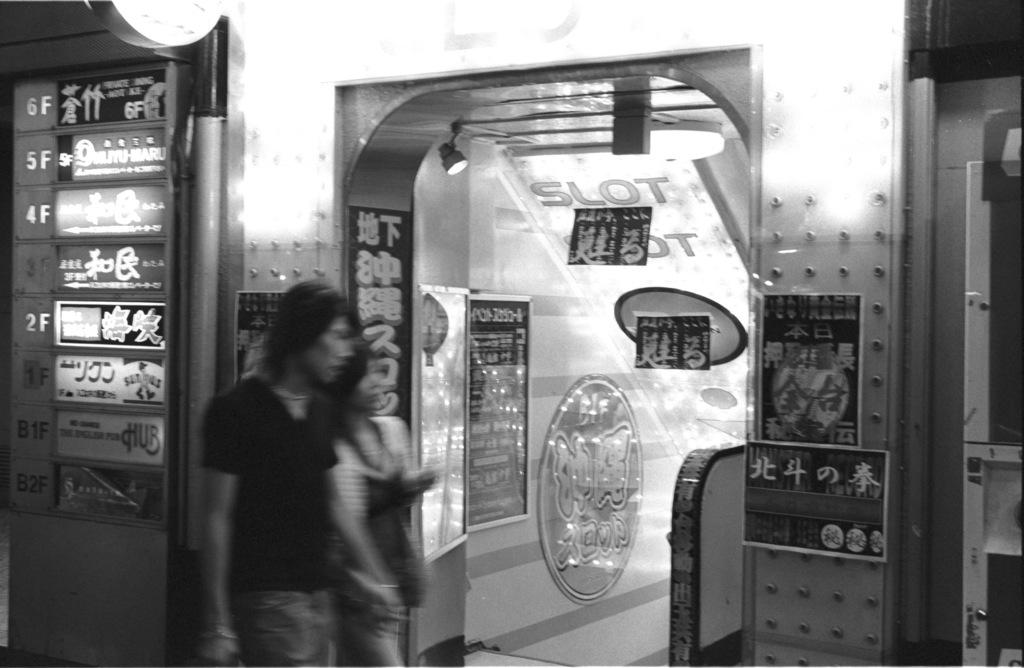What is the color scheme of the image? The image is black and white. How many people are in the image? There are two persons standing in the image. What can be seen in the background of the image? There are boards visible in the image. What type of lighting is present in the image? There are lights in the image. What other objects can be seen in the image besides the people and boards? There are other objects in the image. What is attached to the walls in the image? There are posters attached to the walls in the image. What flavor of soda is being served in the image? There is no soda present in the image, so it is not possible to determine the flavor. What type of crate is visible in the image? There is no crate present in the image. 